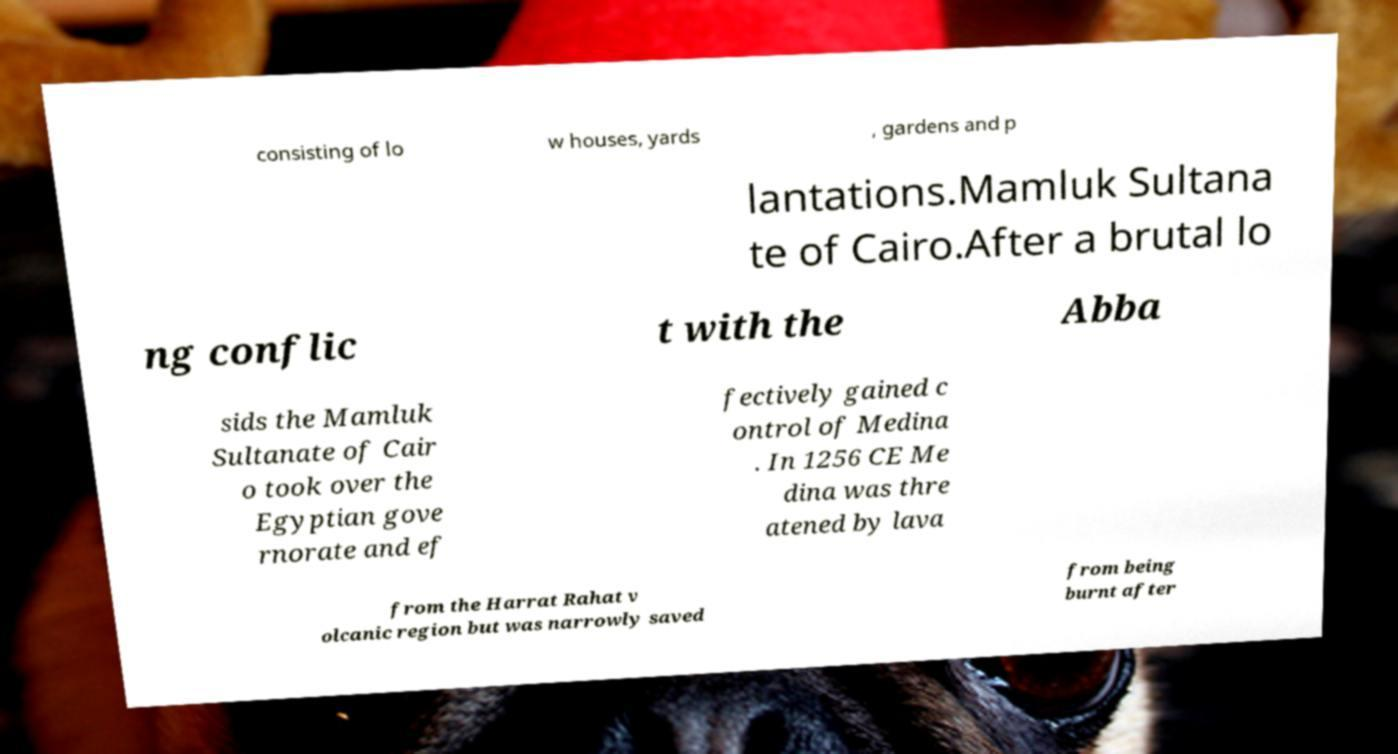For documentation purposes, I need the text within this image transcribed. Could you provide that? consisting of lo w houses, yards , gardens and p lantations.Mamluk Sultana te of Cairo.After a brutal lo ng conflic t with the Abba sids the Mamluk Sultanate of Cair o took over the Egyptian gove rnorate and ef fectively gained c ontrol of Medina . In 1256 CE Me dina was thre atened by lava from the Harrat Rahat v olcanic region but was narrowly saved from being burnt after 